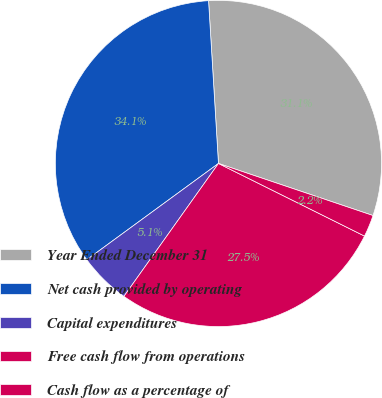Convert chart to OTSL. <chart><loc_0><loc_0><loc_500><loc_500><pie_chart><fcel>Year Ended December 31<fcel>Net cash provided by operating<fcel>Capital expenditures<fcel>Free cash flow from operations<fcel>Cash flow as a percentage of<nl><fcel>31.14%<fcel>34.08%<fcel>5.11%<fcel>27.5%<fcel>2.17%<nl></chart> 